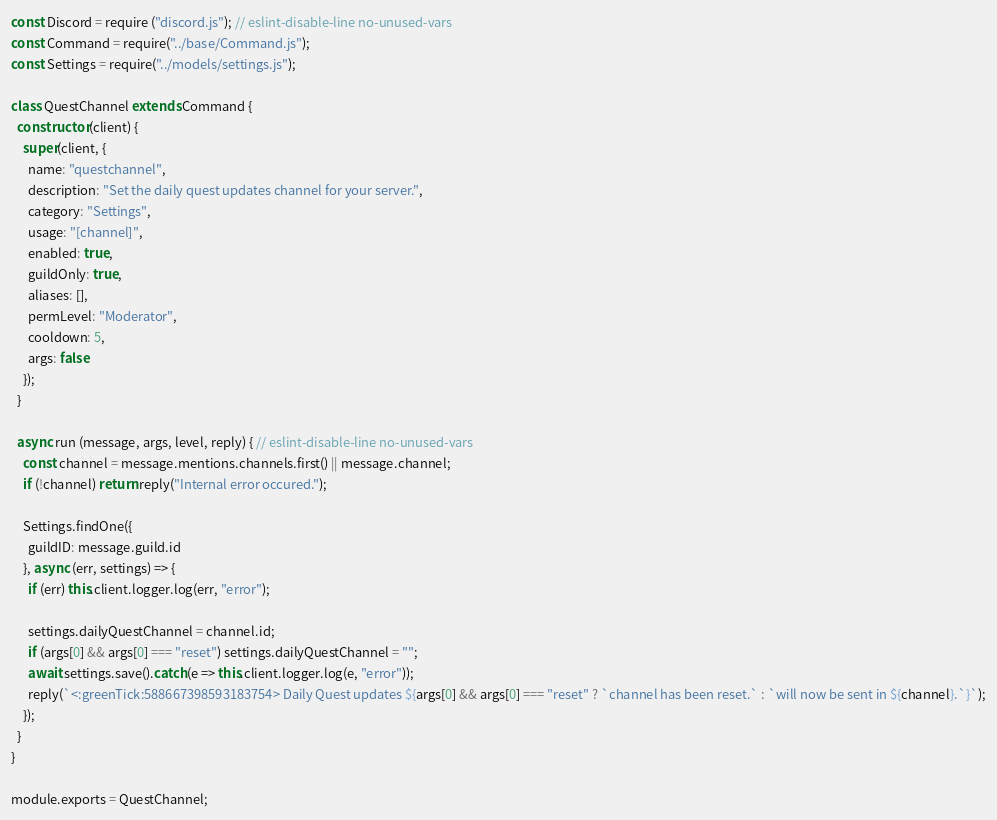<code> <loc_0><loc_0><loc_500><loc_500><_JavaScript_>const Discord = require ("discord.js"); // eslint-disable-line no-unused-vars
const Command = require("../base/Command.js");
const Settings = require("../models/settings.js");

class QuestChannel extends Command {
  constructor (client) {
    super(client, {
      name: "questchannel",
      description: "Set the daily quest updates channel for your server.",
      category: "Settings",
      usage: "[channel]",
      enabled: true,
      guildOnly: true,
      aliases: [],
      permLevel: "Moderator",
      cooldown: 5,
      args: false
    });
  }

  async run (message, args, level, reply) { // eslint-disable-line no-unused-vars
    const channel = message.mentions.channels.first() || message.channel;
    if (!channel) return reply("Internal error occured.");

    Settings.findOne({
      guildID: message.guild.id
    }, async (err, settings) => {
      if (err) this.client.logger.log(err, "error");

      settings.dailyQuestChannel = channel.id;
      if (args[0] && args[0] === "reset") settings.dailyQuestChannel = "";
      await settings.save().catch(e => this.client.logger.log(e, "error"));
      reply(`<:greenTick:588667398593183754> Daily Quest updates ${args[0] && args[0] === "reset" ? `channel has been reset.` : `will now be sent in ${channel}.`}`);
    });
  }
}

module.exports = QuestChannel;
</code> 